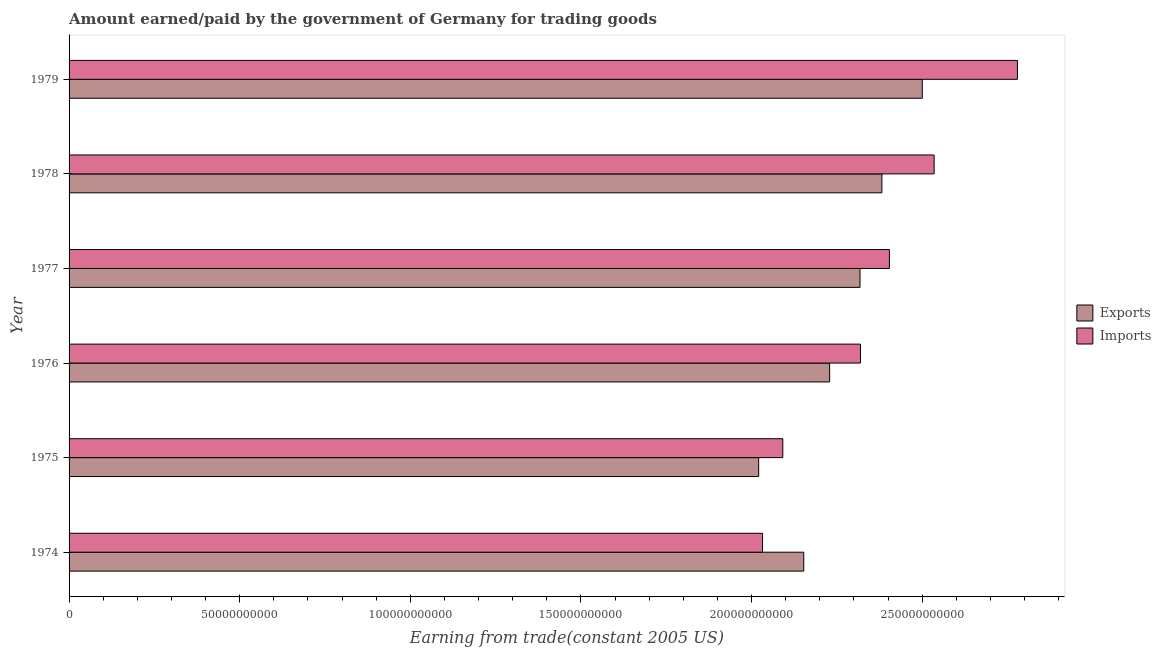Are the number of bars on each tick of the Y-axis equal?
Ensure brevity in your answer.  Yes. What is the label of the 4th group of bars from the top?
Make the answer very short. 1976. In how many cases, is the number of bars for a given year not equal to the number of legend labels?
Provide a succinct answer. 0. What is the amount earned from exports in 1978?
Offer a very short reply. 2.38e+11. Across all years, what is the maximum amount paid for imports?
Keep it short and to the point. 2.78e+11. Across all years, what is the minimum amount paid for imports?
Provide a short and direct response. 2.03e+11. In which year was the amount paid for imports maximum?
Ensure brevity in your answer.  1979. In which year was the amount paid for imports minimum?
Make the answer very short. 1974. What is the total amount paid for imports in the graph?
Offer a very short reply. 1.42e+12. What is the difference between the amount paid for imports in 1978 and that in 1979?
Keep it short and to the point. -2.44e+1. What is the difference between the amount paid for imports in 1974 and the amount earned from exports in 1977?
Offer a terse response. -2.86e+1. What is the average amount paid for imports per year?
Provide a succinct answer. 2.36e+11. In the year 1974, what is the difference between the amount earned from exports and amount paid for imports?
Provide a succinct answer. 1.21e+1. What is the ratio of the amount paid for imports in 1976 to that in 1978?
Offer a terse response. 0.92. Is the amount paid for imports in 1977 less than that in 1979?
Your response must be concise. Yes. Is the difference between the amount paid for imports in 1975 and 1979 greater than the difference between the amount earned from exports in 1975 and 1979?
Give a very brief answer. No. What is the difference between the highest and the second highest amount paid for imports?
Provide a short and direct response. 2.44e+1. What is the difference between the highest and the lowest amount paid for imports?
Give a very brief answer. 7.47e+1. Is the sum of the amount paid for imports in 1975 and 1978 greater than the maximum amount earned from exports across all years?
Your answer should be compact. Yes. What does the 1st bar from the top in 1978 represents?
Give a very brief answer. Imports. What does the 1st bar from the bottom in 1979 represents?
Provide a short and direct response. Exports. How many bars are there?
Your answer should be compact. 12. What is the difference between two consecutive major ticks on the X-axis?
Offer a very short reply. 5.00e+1. Does the graph contain grids?
Provide a short and direct response. No. How are the legend labels stacked?
Provide a succinct answer. Vertical. What is the title of the graph?
Ensure brevity in your answer.  Amount earned/paid by the government of Germany for trading goods. Does "Forest" appear as one of the legend labels in the graph?
Your response must be concise. No. What is the label or title of the X-axis?
Provide a short and direct response. Earning from trade(constant 2005 US). What is the Earning from trade(constant 2005 US) in Exports in 1974?
Provide a succinct answer. 2.15e+11. What is the Earning from trade(constant 2005 US) of Imports in 1974?
Give a very brief answer. 2.03e+11. What is the Earning from trade(constant 2005 US) of Exports in 1975?
Give a very brief answer. 2.02e+11. What is the Earning from trade(constant 2005 US) of Imports in 1975?
Ensure brevity in your answer.  2.09e+11. What is the Earning from trade(constant 2005 US) in Exports in 1976?
Ensure brevity in your answer.  2.23e+11. What is the Earning from trade(constant 2005 US) in Imports in 1976?
Your answer should be very brief. 2.32e+11. What is the Earning from trade(constant 2005 US) in Exports in 1977?
Ensure brevity in your answer.  2.32e+11. What is the Earning from trade(constant 2005 US) in Imports in 1977?
Your response must be concise. 2.40e+11. What is the Earning from trade(constant 2005 US) of Exports in 1978?
Provide a short and direct response. 2.38e+11. What is the Earning from trade(constant 2005 US) of Imports in 1978?
Ensure brevity in your answer.  2.53e+11. What is the Earning from trade(constant 2005 US) in Exports in 1979?
Ensure brevity in your answer.  2.50e+11. What is the Earning from trade(constant 2005 US) of Imports in 1979?
Keep it short and to the point. 2.78e+11. Across all years, what is the maximum Earning from trade(constant 2005 US) of Exports?
Keep it short and to the point. 2.50e+11. Across all years, what is the maximum Earning from trade(constant 2005 US) in Imports?
Your response must be concise. 2.78e+11. Across all years, what is the minimum Earning from trade(constant 2005 US) in Exports?
Your response must be concise. 2.02e+11. Across all years, what is the minimum Earning from trade(constant 2005 US) of Imports?
Your answer should be compact. 2.03e+11. What is the total Earning from trade(constant 2005 US) of Exports in the graph?
Keep it short and to the point. 1.36e+12. What is the total Earning from trade(constant 2005 US) in Imports in the graph?
Offer a terse response. 1.42e+12. What is the difference between the Earning from trade(constant 2005 US) of Exports in 1974 and that in 1975?
Provide a short and direct response. 1.32e+1. What is the difference between the Earning from trade(constant 2005 US) of Imports in 1974 and that in 1975?
Provide a succinct answer. -5.94e+09. What is the difference between the Earning from trade(constant 2005 US) in Exports in 1974 and that in 1976?
Ensure brevity in your answer.  -7.58e+09. What is the difference between the Earning from trade(constant 2005 US) of Imports in 1974 and that in 1976?
Give a very brief answer. -2.87e+1. What is the difference between the Earning from trade(constant 2005 US) of Exports in 1974 and that in 1977?
Offer a very short reply. -1.65e+1. What is the difference between the Earning from trade(constant 2005 US) in Imports in 1974 and that in 1977?
Your response must be concise. -3.72e+1. What is the difference between the Earning from trade(constant 2005 US) in Exports in 1974 and that in 1978?
Make the answer very short. -2.29e+1. What is the difference between the Earning from trade(constant 2005 US) in Imports in 1974 and that in 1978?
Give a very brief answer. -5.03e+1. What is the difference between the Earning from trade(constant 2005 US) in Exports in 1974 and that in 1979?
Your answer should be very brief. -3.47e+1. What is the difference between the Earning from trade(constant 2005 US) in Imports in 1974 and that in 1979?
Provide a succinct answer. -7.47e+1. What is the difference between the Earning from trade(constant 2005 US) in Exports in 1975 and that in 1976?
Keep it short and to the point. -2.08e+1. What is the difference between the Earning from trade(constant 2005 US) of Imports in 1975 and that in 1976?
Ensure brevity in your answer.  -2.28e+1. What is the difference between the Earning from trade(constant 2005 US) of Exports in 1975 and that in 1977?
Offer a very short reply. -2.97e+1. What is the difference between the Earning from trade(constant 2005 US) of Imports in 1975 and that in 1977?
Offer a very short reply. -3.12e+1. What is the difference between the Earning from trade(constant 2005 US) in Exports in 1975 and that in 1978?
Make the answer very short. -3.61e+1. What is the difference between the Earning from trade(constant 2005 US) in Imports in 1975 and that in 1978?
Provide a short and direct response. -4.43e+1. What is the difference between the Earning from trade(constant 2005 US) in Exports in 1975 and that in 1979?
Provide a short and direct response. -4.79e+1. What is the difference between the Earning from trade(constant 2005 US) of Imports in 1975 and that in 1979?
Make the answer very short. -6.88e+1. What is the difference between the Earning from trade(constant 2005 US) of Exports in 1976 and that in 1977?
Give a very brief answer. -8.90e+09. What is the difference between the Earning from trade(constant 2005 US) in Imports in 1976 and that in 1977?
Ensure brevity in your answer.  -8.48e+09. What is the difference between the Earning from trade(constant 2005 US) in Exports in 1976 and that in 1978?
Your response must be concise. -1.53e+1. What is the difference between the Earning from trade(constant 2005 US) of Imports in 1976 and that in 1978?
Your response must be concise. -2.16e+1. What is the difference between the Earning from trade(constant 2005 US) in Exports in 1976 and that in 1979?
Provide a succinct answer. -2.72e+1. What is the difference between the Earning from trade(constant 2005 US) in Imports in 1976 and that in 1979?
Your response must be concise. -4.60e+1. What is the difference between the Earning from trade(constant 2005 US) in Exports in 1977 and that in 1978?
Provide a succinct answer. -6.41e+09. What is the difference between the Earning from trade(constant 2005 US) of Imports in 1977 and that in 1978?
Keep it short and to the point. -1.31e+1. What is the difference between the Earning from trade(constant 2005 US) of Exports in 1977 and that in 1979?
Keep it short and to the point. -1.82e+1. What is the difference between the Earning from trade(constant 2005 US) of Imports in 1977 and that in 1979?
Ensure brevity in your answer.  -3.75e+1. What is the difference between the Earning from trade(constant 2005 US) in Exports in 1978 and that in 1979?
Ensure brevity in your answer.  -1.18e+1. What is the difference between the Earning from trade(constant 2005 US) in Imports in 1978 and that in 1979?
Provide a short and direct response. -2.44e+1. What is the difference between the Earning from trade(constant 2005 US) of Exports in 1974 and the Earning from trade(constant 2005 US) of Imports in 1975?
Keep it short and to the point. 6.14e+09. What is the difference between the Earning from trade(constant 2005 US) in Exports in 1974 and the Earning from trade(constant 2005 US) in Imports in 1976?
Make the answer very short. -1.66e+1. What is the difference between the Earning from trade(constant 2005 US) of Exports in 1974 and the Earning from trade(constant 2005 US) of Imports in 1977?
Offer a terse response. -2.51e+1. What is the difference between the Earning from trade(constant 2005 US) of Exports in 1974 and the Earning from trade(constant 2005 US) of Imports in 1978?
Provide a succinct answer. -3.82e+1. What is the difference between the Earning from trade(constant 2005 US) of Exports in 1974 and the Earning from trade(constant 2005 US) of Imports in 1979?
Your answer should be compact. -6.26e+1. What is the difference between the Earning from trade(constant 2005 US) of Exports in 1975 and the Earning from trade(constant 2005 US) of Imports in 1976?
Offer a terse response. -2.98e+1. What is the difference between the Earning from trade(constant 2005 US) of Exports in 1975 and the Earning from trade(constant 2005 US) of Imports in 1977?
Offer a very short reply. -3.83e+1. What is the difference between the Earning from trade(constant 2005 US) of Exports in 1975 and the Earning from trade(constant 2005 US) of Imports in 1978?
Offer a very short reply. -5.14e+1. What is the difference between the Earning from trade(constant 2005 US) of Exports in 1975 and the Earning from trade(constant 2005 US) of Imports in 1979?
Your response must be concise. -7.58e+1. What is the difference between the Earning from trade(constant 2005 US) of Exports in 1976 and the Earning from trade(constant 2005 US) of Imports in 1977?
Make the answer very short. -1.75e+1. What is the difference between the Earning from trade(constant 2005 US) of Exports in 1976 and the Earning from trade(constant 2005 US) of Imports in 1978?
Keep it short and to the point. -3.06e+1. What is the difference between the Earning from trade(constant 2005 US) of Exports in 1976 and the Earning from trade(constant 2005 US) of Imports in 1979?
Your answer should be very brief. -5.50e+1. What is the difference between the Earning from trade(constant 2005 US) in Exports in 1977 and the Earning from trade(constant 2005 US) in Imports in 1978?
Give a very brief answer. -2.17e+1. What is the difference between the Earning from trade(constant 2005 US) in Exports in 1977 and the Earning from trade(constant 2005 US) in Imports in 1979?
Provide a short and direct response. -4.61e+1. What is the difference between the Earning from trade(constant 2005 US) of Exports in 1978 and the Earning from trade(constant 2005 US) of Imports in 1979?
Ensure brevity in your answer.  -3.97e+1. What is the average Earning from trade(constant 2005 US) in Exports per year?
Your response must be concise. 2.27e+11. What is the average Earning from trade(constant 2005 US) of Imports per year?
Make the answer very short. 2.36e+11. In the year 1974, what is the difference between the Earning from trade(constant 2005 US) of Exports and Earning from trade(constant 2005 US) of Imports?
Your response must be concise. 1.21e+1. In the year 1975, what is the difference between the Earning from trade(constant 2005 US) of Exports and Earning from trade(constant 2005 US) of Imports?
Your answer should be compact. -7.07e+09. In the year 1976, what is the difference between the Earning from trade(constant 2005 US) of Exports and Earning from trade(constant 2005 US) of Imports?
Your answer should be very brief. -9.04e+09. In the year 1977, what is the difference between the Earning from trade(constant 2005 US) in Exports and Earning from trade(constant 2005 US) in Imports?
Provide a succinct answer. -8.61e+09. In the year 1978, what is the difference between the Earning from trade(constant 2005 US) of Exports and Earning from trade(constant 2005 US) of Imports?
Provide a short and direct response. -1.53e+1. In the year 1979, what is the difference between the Earning from trade(constant 2005 US) in Exports and Earning from trade(constant 2005 US) in Imports?
Your response must be concise. -2.79e+1. What is the ratio of the Earning from trade(constant 2005 US) of Exports in 1974 to that in 1975?
Your response must be concise. 1.07. What is the ratio of the Earning from trade(constant 2005 US) in Imports in 1974 to that in 1975?
Offer a terse response. 0.97. What is the ratio of the Earning from trade(constant 2005 US) in Exports in 1974 to that in 1976?
Ensure brevity in your answer.  0.97. What is the ratio of the Earning from trade(constant 2005 US) of Imports in 1974 to that in 1976?
Provide a short and direct response. 0.88. What is the ratio of the Earning from trade(constant 2005 US) in Exports in 1974 to that in 1977?
Offer a very short reply. 0.93. What is the ratio of the Earning from trade(constant 2005 US) in Imports in 1974 to that in 1977?
Provide a short and direct response. 0.85. What is the ratio of the Earning from trade(constant 2005 US) in Exports in 1974 to that in 1978?
Your answer should be compact. 0.9. What is the ratio of the Earning from trade(constant 2005 US) of Imports in 1974 to that in 1978?
Give a very brief answer. 0.8. What is the ratio of the Earning from trade(constant 2005 US) in Exports in 1974 to that in 1979?
Make the answer very short. 0.86. What is the ratio of the Earning from trade(constant 2005 US) in Imports in 1974 to that in 1979?
Offer a terse response. 0.73. What is the ratio of the Earning from trade(constant 2005 US) in Exports in 1975 to that in 1976?
Offer a terse response. 0.91. What is the ratio of the Earning from trade(constant 2005 US) of Imports in 1975 to that in 1976?
Make the answer very short. 0.9. What is the ratio of the Earning from trade(constant 2005 US) of Exports in 1975 to that in 1977?
Your answer should be very brief. 0.87. What is the ratio of the Earning from trade(constant 2005 US) in Imports in 1975 to that in 1977?
Keep it short and to the point. 0.87. What is the ratio of the Earning from trade(constant 2005 US) in Exports in 1975 to that in 1978?
Provide a short and direct response. 0.85. What is the ratio of the Earning from trade(constant 2005 US) of Imports in 1975 to that in 1978?
Offer a terse response. 0.83. What is the ratio of the Earning from trade(constant 2005 US) in Exports in 1975 to that in 1979?
Provide a short and direct response. 0.81. What is the ratio of the Earning from trade(constant 2005 US) in Imports in 1975 to that in 1979?
Make the answer very short. 0.75. What is the ratio of the Earning from trade(constant 2005 US) of Exports in 1976 to that in 1977?
Your answer should be compact. 0.96. What is the ratio of the Earning from trade(constant 2005 US) in Imports in 1976 to that in 1977?
Give a very brief answer. 0.96. What is the ratio of the Earning from trade(constant 2005 US) in Exports in 1976 to that in 1978?
Your answer should be compact. 0.94. What is the ratio of the Earning from trade(constant 2005 US) in Imports in 1976 to that in 1978?
Keep it short and to the point. 0.91. What is the ratio of the Earning from trade(constant 2005 US) of Exports in 1976 to that in 1979?
Your answer should be very brief. 0.89. What is the ratio of the Earning from trade(constant 2005 US) of Imports in 1976 to that in 1979?
Provide a short and direct response. 0.83. What is the ratio of the Earning from trade(constant 2005 US) in Exports in 1977 to that in 1978?
Keep it short and to the point. 0.97. What is the ratio of the Earning from trade(constant 2005 US) in Imports in 1977 to that in 1978?
Provide a short and direct response. 0.95. What is the ratio of the Earning from trade(constant 2005 US) in Exports in 1977 to that in 1979?
Keep it short and to the point. 0.93. What is the ratio of the Earning from trade(constant 2005 US) of Imports in 1977 to that in 1979?
Offer a very short reply. 0.86. What is the ratio of the Earning from trade(constant 2005 US) of Exports in 1978 to that in 1979?
Ensure brevity in your answer.  0.95. What is the ratio of the Earning from trade(constant 2005 US) in Imports in 1978 to that in 1979?
Your answer should be compact. 0.91. What is the difference between the highest and the second highest Earning from trade(constant 2005 US) in Exports?
Offer a very short reply. 1.18e+1. What is the difference between the highest and the second highest Earning from trade(constant 2005 US) in Imports?
Your response must be concise. 2.44e+1. What is the difference between the highest and the lowest Earning from trade(constant 2005 US) in Exports?
Offer a terse response. 4.79e+1. What is the difference between the highest and the lowest Earning from trade(constant 2005 US) in Imports?
Provide a succinct answer. 7.47e+1. 